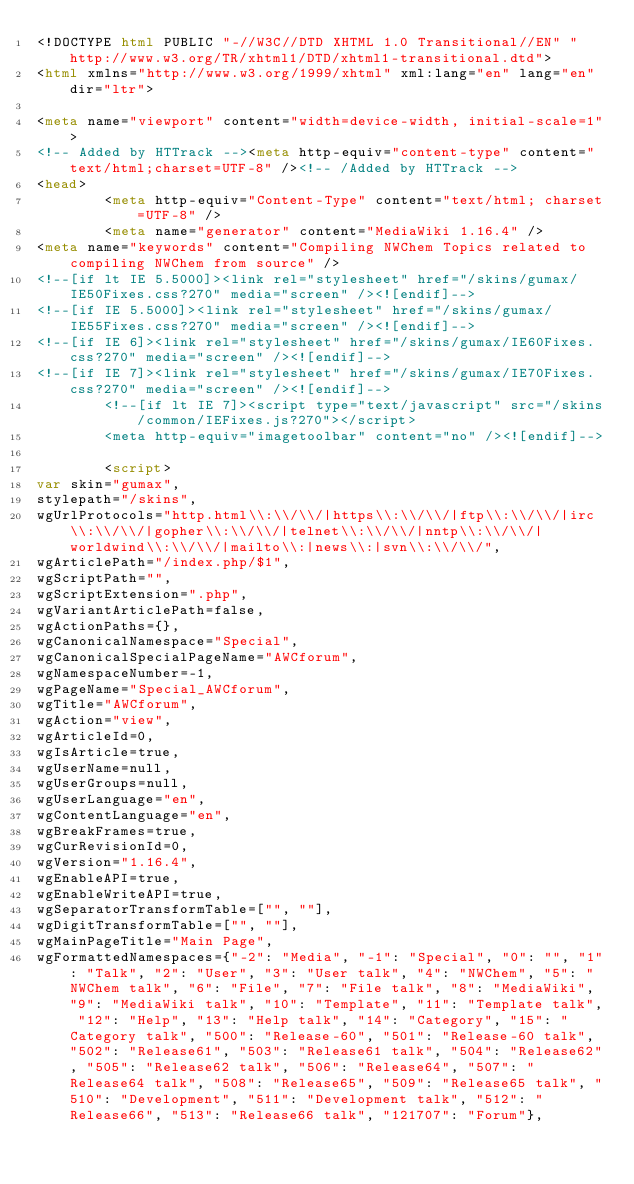<code> <loc_0><loc_0><loc_500><loc_500><_HTML_><!DOCTYPE html PUBLIC "-//W3C//DTD XHTML 1.0 Transitional//EN" "http://www.w3.org/TR/xhtml1/DTD/xhtml1-transitional.dtd">
<html xmlns="http://www.w3.org/1999/xhtml" xml:lang="en" lang="en" dir="ltr">
	
<meta name="viewport" content="width=device-width, initial-scale=1">
<!-- Added by HTTrack --><meta http-equiv="content-type" content="text/html;charset=UTF-8" /><!-- /Added by HTTrack -->
<head>
		<meta http-equiv="Content-Type" content="text/html; charset=UTF-8" />
		<meta name="generator" content="MediaWiki 1.16.4" />
<meta name="keywords" content="Compiling NWChem Topics related to compiling NWChem from source" />
<!--[if lt IE 5.5000]><link rel="stylesheet" href="/skins/gumax/IE50Fixes.css?270" media="screen" /><![endif]-->
<!--[if IE 5.5000]><link rel="stylesheet" href="/skins/gumax/IE55Fixes.css?270" media="screen" /><![endif]-->
<!--[if IE 6]><link rel="stylesheet" href="/skins/gumax/IE60Fixes.css?270" media="screen" /><![endif]-->
<!--[if IE 7]><link rel="stylesheet" href="/skins/gumax/IE70Fixes.css?270" media="screen" /><![endif]-->
		<!--[if lt IE 7]><script type="text/javascript" src="/skins/common/IEFixes.js?270"></script>
		<meta http-equiv="imagetoolbar" content="no" /><![endif]-->

		<script>
var skin="gumax",
stylepath="/skins",
wgUrlProtocols="http.html\\:\\/\\/|https\\:\\/\\/|ftp\\:\\/\\/|irc\\:\\/\\/|gopher\\:\\/\\/|telnet\\:\\/\\/|nntp\\:\\/\\/|worldwind\\:\\/\\/|mailto\\:|news\\:|svn\\:\\/\\/",
wgArticlePath="/index.php/$1",
wgScriptPath="",
wgScriptExtension=".php",
wgVariantArticlePath=false,
wgActionPaths={},
wgCanonicalNamespace="Special",
wgCanonicalSpecialPageName="AWCforum",
wgNamespaceNumber=-1,
wgPageName="Special_AWCforum",
wgTitle="AWCforum",
wgAction="view",
wgArticleId=0,
wgIsArticle=true,
wgUserName=null,
wgUserGroups=null,
wgUserLanguage="en",
wgContentLanguage="en",
wgBreakFrames=true,
wgCurRevisionId=0,
wgVersion="1.16.4",
wgEnableAPI=true,
wgEnableWriteAPI=true,
wgSeparatorTransformTable=["", ""],
wgDigitTransformTable=["", ""],
wgMainPageTitle="Main Page",
wgFormattedNamespaces={"-2": "Media", "-1": "Special", "0": "", "1": "Talk", "2": "User", "3": "User talk", "4": "NWChem", "5": "NWChem talk", "6": "File", "7": "File talk", "8": "MediaWiki", "9": "MediaWiki talk", "10": "Template", "11": "Template talk", "12": "Help", "13": "Help talk", "14": "Category", "15": "Category talk", "500": "Release-60", "501": "Release-60 talk", "502": "Release61", "503": "Release61 talk", "504": "Release62", "505": "Release62 talk", "506": "Release64", "507": "Release64 talk", "508": "Release65", "509": "Release65 talk", "510": "Development", "511": "Development talk", "512": "Release66", "513": "Release66 talk", "121707": "Forum"},</code> 